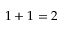<formula> <loc_0><loc_0><loc_500><loc_500>1 + 1 = 2</formula> 